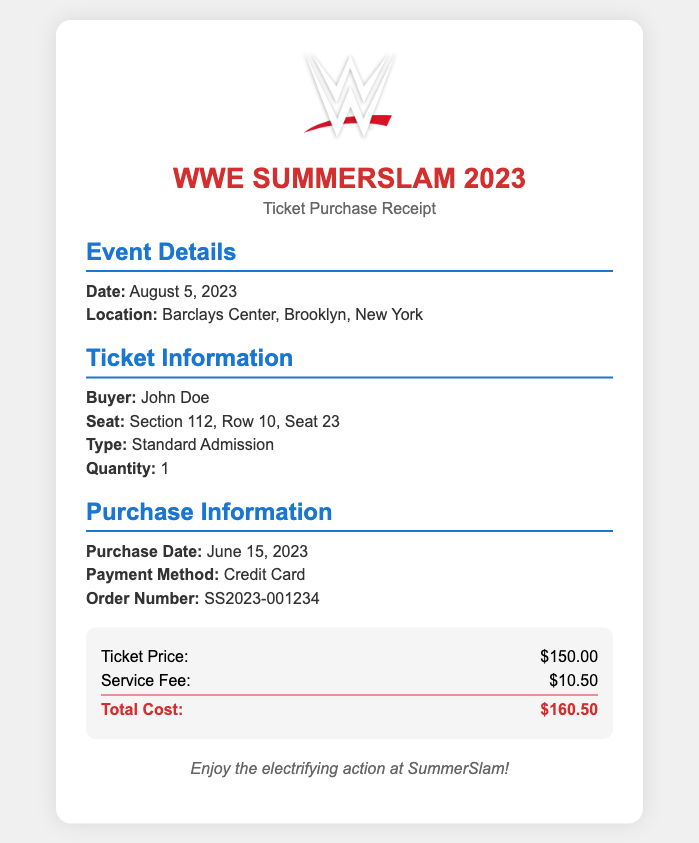what is the date of the event? The date of the event is mentioned in the "Event Details" section, which specifies August 5, 2023.
Answer: August 5, 2023 where is the event taking place? The location of the event is provided under "Event Details," indicating it will be held at Barclays Center, Brooklyn, New York.
Answer: Barclays Center, Brooklyn, New York who is the ticket buyer? The ticket buyer's name is listed in the "Ticket Information" section as John Doe.
Answer: John Doe what type of ticket was purchased? The type of ticket is stated in the "Ticket Information" section, specifying it as Standard Admission.
Answer: Standard Admission how much was the ticket price? The ticket price is detailed in the "cost" section, indicating a price of $150.00.
Answer: $150.00 what is the total cost of the ticket? The total cost can be found in the "cost" section, summarizing the ticket price and service fee, which amounts to $160.50.
Answer: $160.50 how many tickets were purchased? The quantity of tickets purchased is specified in the "Ticket Information" section as 1.
Answer: 1 when was the ticket purchased? The purchase date is mentioned in the "Purchase Information" section, indicating it was made on June 15, 2023.
Answer: June 15, 2023 what is the order number for this transaction? The order number is listed in the "Purchase Information" section as SS2023-001234.
Answer: SS2023-001234 